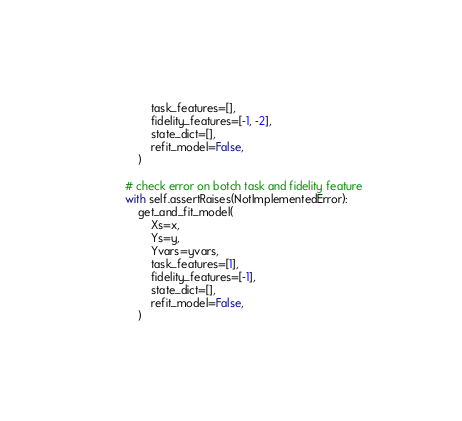Convert code to text. <code><loc_0><loc_0><loc_500><loc_500><_Python_>                task_features=[],
                fidelity_features=[-1, -2],
                state_dict=[],
                refit_model=False,
            )

        # check error on botch task and fidelity feature
        with self.assertRaises(NotImplementedError):
            get_and_fit_model(
                Xs=x,
                Ys=y,
                Yvars=yvars,
                task_features=[1],
                fidelity_features=[-1],
                state_dict=[],
                refit_model=False,
            )
</code> 